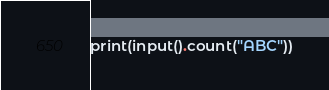Convert code to text. <code><loc_0><loc_0><loc_500><loc_500><_Python_>print(input().count("ABC"))</code> 